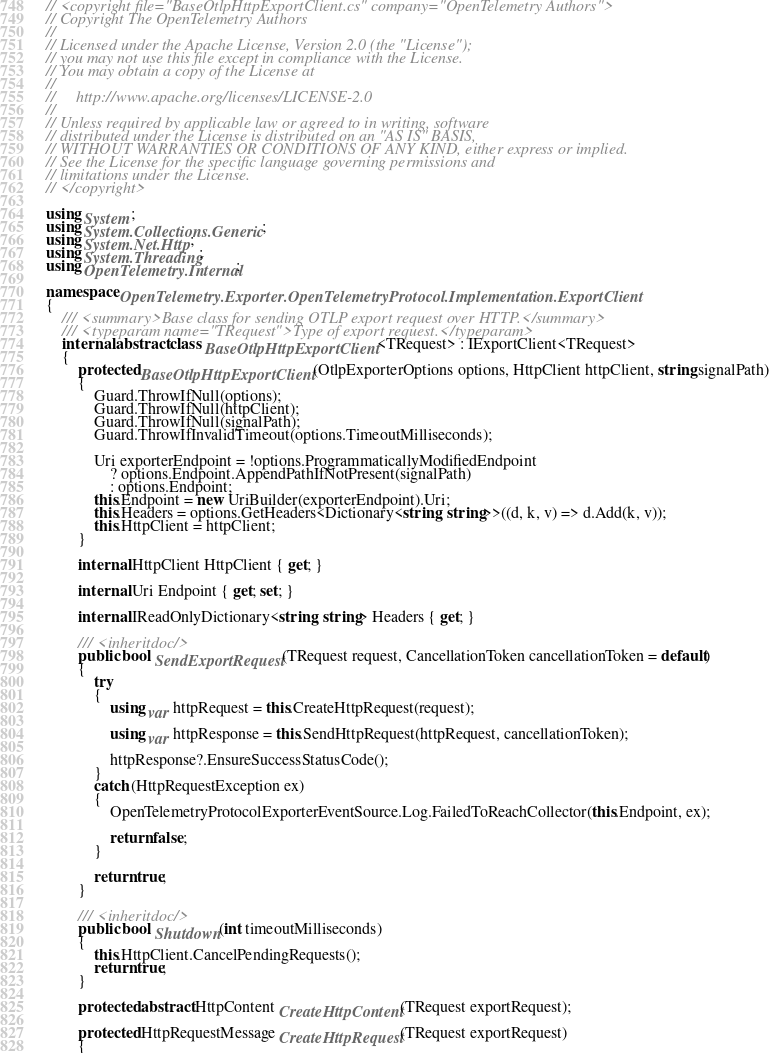<code> <loc_0><loc_0><loc_500><loc_500><_C#_>// <copyright file="BaseOtlpHttpExportClient.cs" company="OpenTelemetry Authors">
// Copyright The OpenTelemetry Authors
//
// Licensed under the Apache License, Version 2.0 (the "License");
// you may not use this file except in compliance with the License.
// You may obtain a copy of the License at
//
//     http://www.apache.org/licenses/LICENSE-2.0
//
// Unless required by applicable law or agreed to in writing, software
// distributed under the License is distributed on an "AS IS" BASIS,
// WITHOUT WARRANTIES OR CONDITIONS OF ANY KIND, either express or implied.
// See the License for the specific language governing permissions and
// limitations under the License.
// </copyright>

using System;
using System.Collections.Generic;
using System.Net.Http;
using System.Threading;
using OpenTelemetry.Internal;

namespace OpenTelemetry.Exporter.OpenTelemetryProtocol.Implementation.ExportClient
{
    /// <summary>Base class for sending OTLP export request over HTTP.</summary>
    /// <typeparam name="TRequest">Type of export request.</typeparam>
    internal abstract class BaseOtlpHttpExportClient<TRequest> : IExportClient<TRequest>
    {
        protected BaseOtlpHttpExportClient(OtlpExporterOptions options, HttpClient httpClient, string signalPath)
        {
            Guard.ThrowIfNull(options);
            Guard.ThrowIfNull(httpClient);
            Guard.ThrowIfNull(signalPath);
            Guard.ThrowIfInvalidTimeout(options.TimeoutMilliseconds);

            Uri exporterEndpoint = !options.ProgrammaticallyModifiedEndpoint
                ? options.Endpoint.AppendPathIfNotPresent(signalPath)
                : options.Endpoint;
            this.Endpoint = new UriBuilder(exporterEndpoint).Uri;
            this.Headers = options.GetHeaders<Dictionary<string, string>>((d, k, v) => d.Add(k, v));
            this.HttpClient = httpClient;
        }

        internal HttpClient HttpClient { get; }

        internal Uri Endpoint { get; set; }

        internal IReadOnlyDictionary<string, string> Headers { get; }

        /// <inheritdoc/>
        public bool SendExportRequest(TRequest request, CancellationToken cancellationToken = default)
        {
            try
            {
                using var httpRequest = this.CreateHttpRequest(request);

                using var httpResponse = this.SendHttpRequest(httpRequest, cancellationToken);

                httpResponse?.EnsureSuccessStatusCode();
            }
            catch (HttpRequestException ex)
            {
                OpenTelemetryProtocolExporterEventSource.Log.FailedToReachCollector(this.Endpoint, ex);

                return false;
            }

            return true;
        }

        /// <inheritdoc/>
        public bool Shutdown(int timeoutMilliseconds)
        {
            this.HttpClient.CancelPendingRequests();
            return true;
        }

        protected abstract HttpContent CreateHttpContent(TRequest exportRequest);

        protected HttpRequestMessage CreateHttpRequest(TRequest exportRequest)
        {</code> 